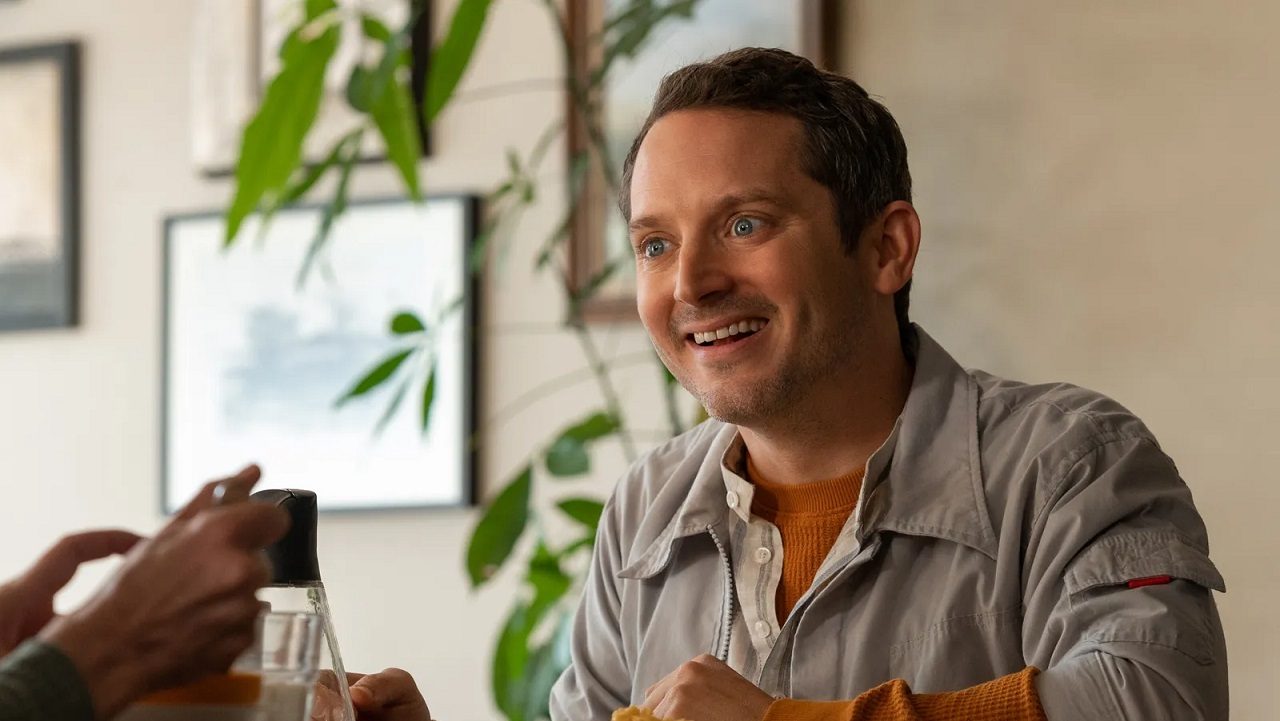Describe a realistic short scenario involving the person in the image. Ethan is meeting his friend at their favorite café to catch up after several busy weeks. They talk about their latest projects, laugh over old memories, and make plans for the weekend. The relaxed environment and warm conversation offer a much-needed break from their hectic schedules. 